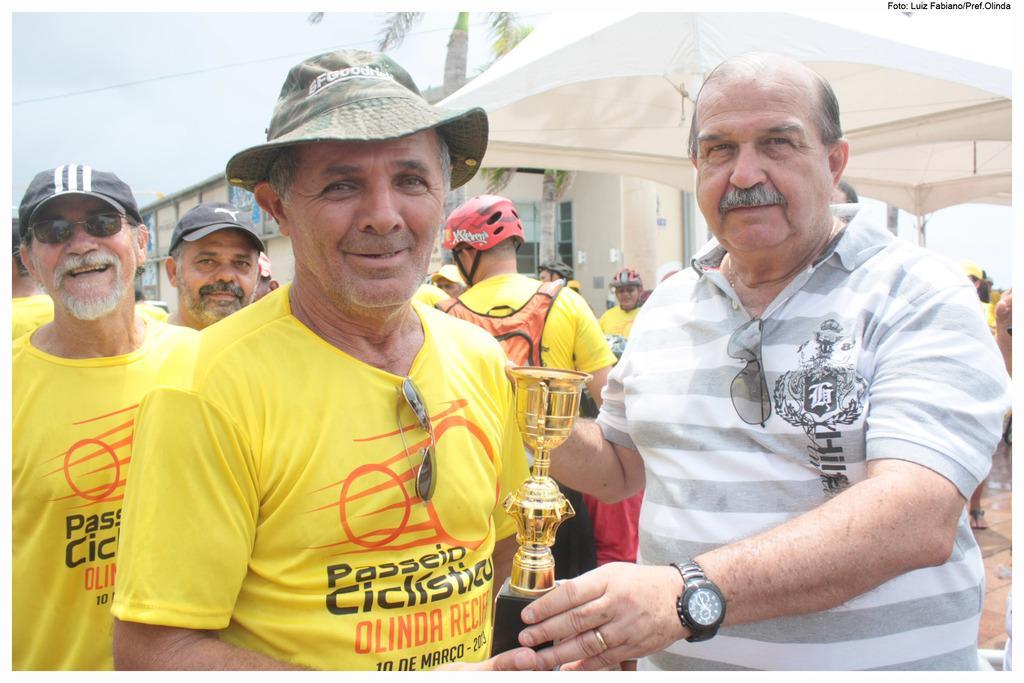Could you give a brief overview of what you see in this image? This is the picture of a place where we have a person in yellow tee shirt, hat and beside there is an other person and they are holding the memento and behind there are some other people, buildings and a tree. 